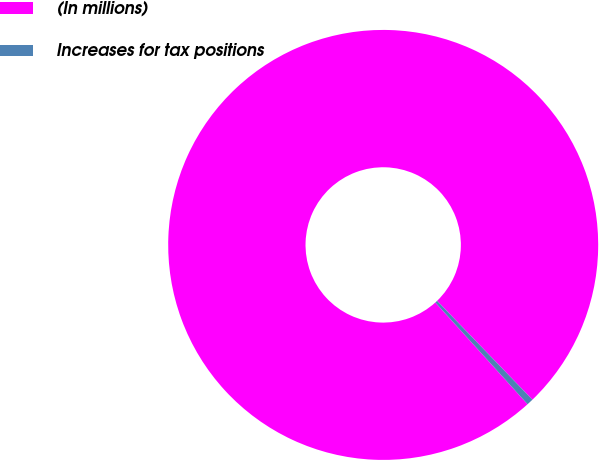Convert chart. <chart><loc_0><loc_0><loc_500><loc_500><pie_chart><fcel>(In millions)<fcel>Increases for tax positions<nl><fcel>99.51%<fcel>0.49%<nl></chart> 